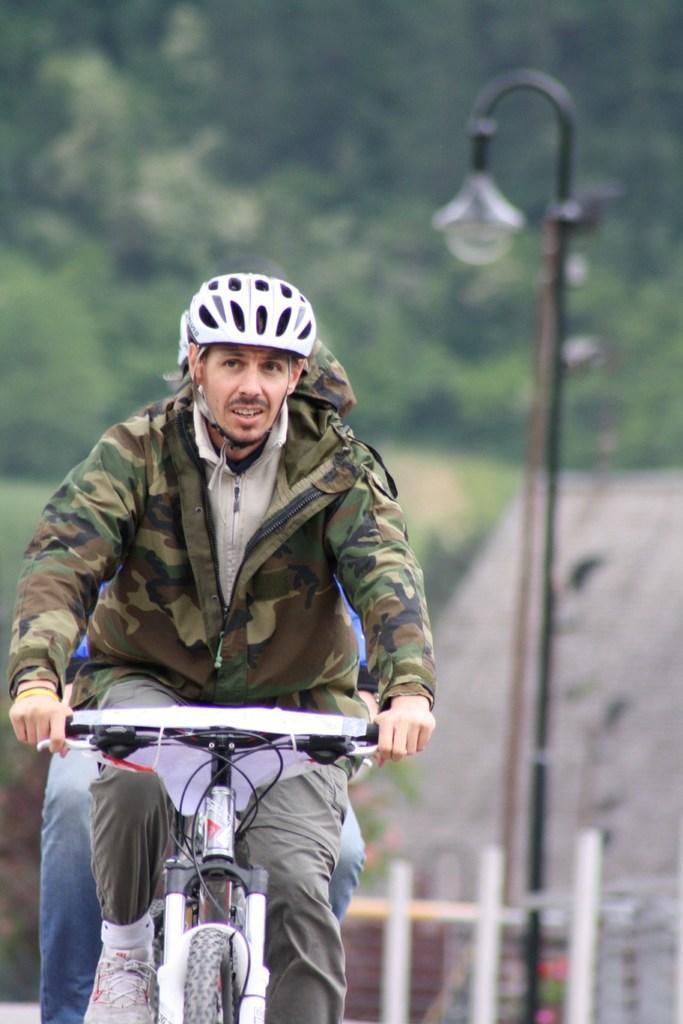Could you give a brief overview of what you see in this image? As we can see in the image there are trees and a man riding bicycle. On the right side there is a street lamp. 